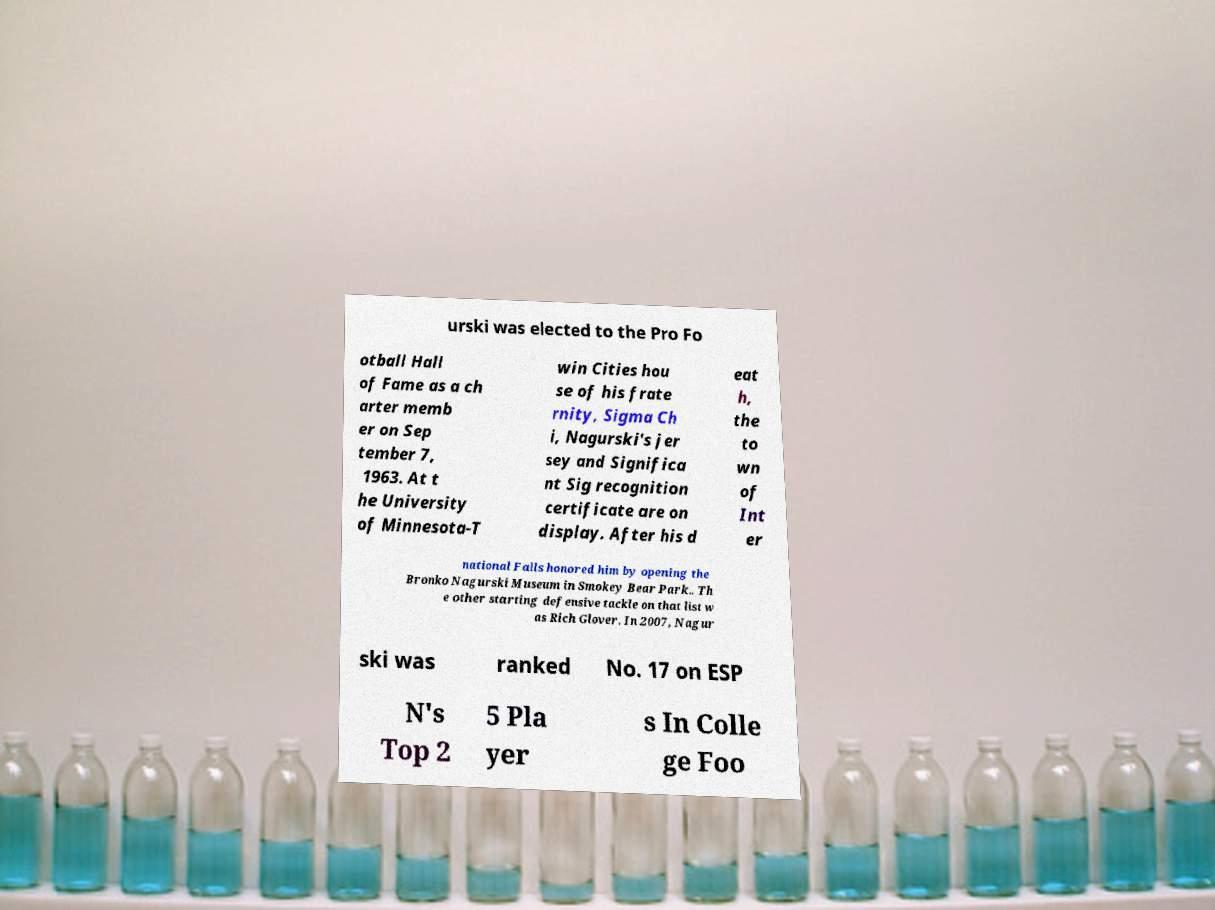Could you extract and type out the text from this image? urski was elected to the Pro Fo otball Hall of Fame as a ch arter memb er on Sep tember 7, 1963. At t he University of Minnesota-T win Cities hou se of his frate rnity, Sigma Ch i, Nagurski's jer sey and Significa nt Sig recognition certificate are on display. After his d eat h, the to wn of Int er national Falls honored him by opening the Bronko Nagurski Museum in Smokey Bear Park.. Th e other starting defensive tackle on that list w as Rich Glover. In 2007, Nagur ski was ranked No. 17 on ESP N's Top 2 5 Pla yer s In Colle ge Foo 